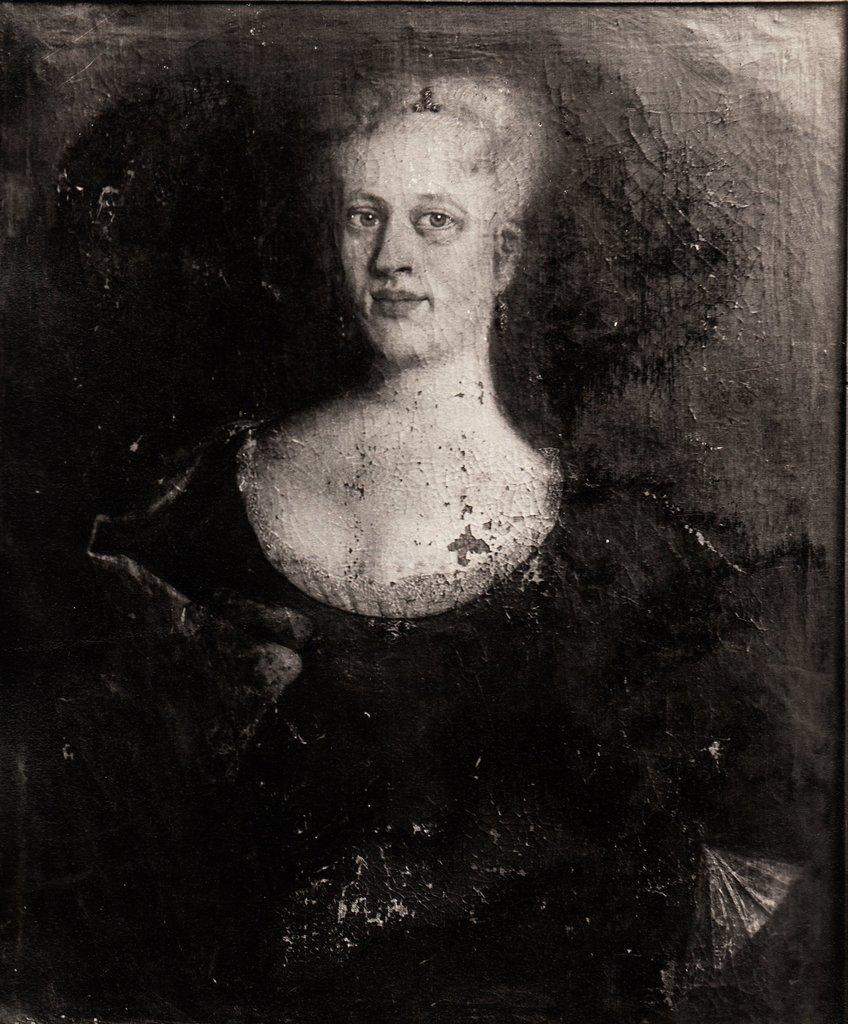What is the main subject of the image? The main subject of the image is an art of a person. How many pies are being held by the person in the image? There is no indication of pies in the image; it features an art of a person. How many sisters does the person in the image have? There is no information about the person's sisters in the image. 